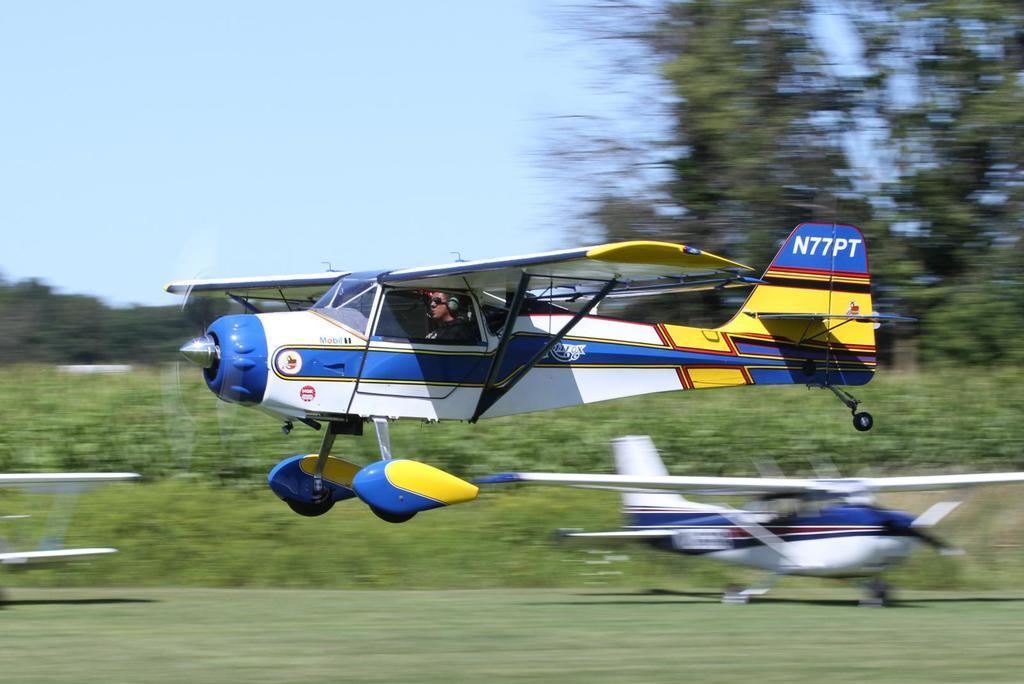Please provide a concise description of this image. In this picture I can see 3 aircrafts and I can see the grass, plants and the trees. In the background I can see the sky and I see that this image is a bit blurry. 